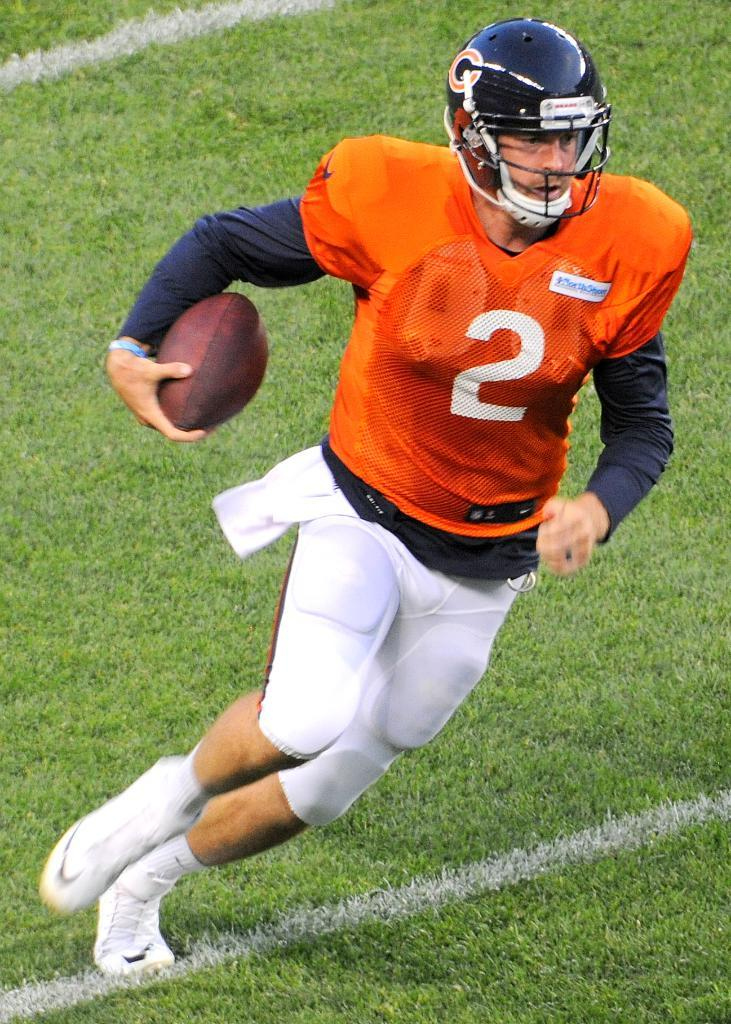Who is present in the image? There is a man in the image. What is the man's position in relation to the ground? The man is standing on the ground. What object is the man holding in his hands? The man is holding a ball in his hands. What type of cannon is visible on the edge of the image? There is no cannon present in the image, and the edge of the image is not mentioned in the provided facts. 